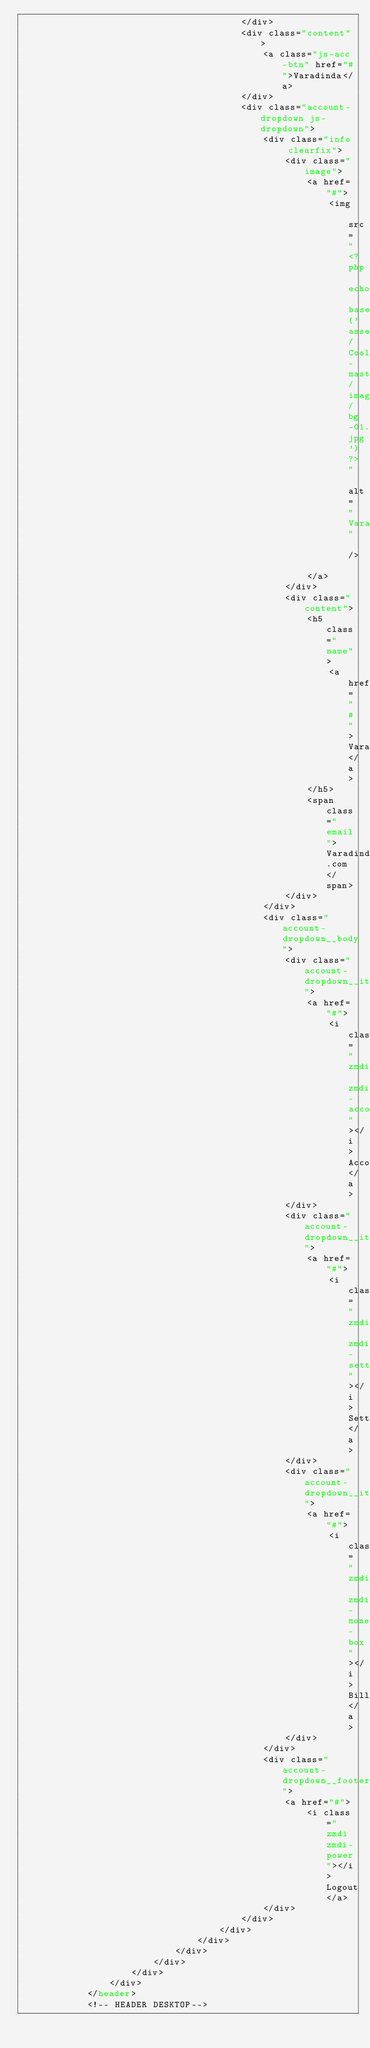<code> <loc_0><loc_0><loc_500><loc_500><_PHP_>                                        </div>
                                        <div class="content">
                                            <a class="js-acc-btn" href="#">Varadinda</a>
                                        </div>
                                        <div class="account-dropdown js-dropdown">
                                            <div class="info clearfix">
                                                <div class="image">
                                                    <a href="#">
                                                        <img src="<?php echo base_url('assets/Cooladmin-master/images/bg-01.jpg')?>" alt="Varadinda" />
                                                    </a>
                                                </div>
                                                <div class="content">
                                                    <h5 class="name">
                                                        <a href="#">Varadinda</a>
                                                    </h5>
                                                    <span class="email">Varadinda@gmail.com</span>
                                                </div>
                                            </div>
                                            <div class="account-dropdown__body">
                                                <div class="account-dropdown__item">
                                                    <a href="#">
                                                        <i class="zmdi zmdi-account"></i>Account</a>
                                                </div>
                                                <div class="account-dropdown__item">
                                                    <a href="#">
                                                        <i class="zmdi zmdi-settings"></i>Setting</a>
                                                </div>
                                                <div class="account-dropdown__item">
                                                    <a href="#">
                                                        <i class="zmdi zmdi-money-box"></i>Billing</a>
                                                </div>
                                            </div>
                                            <div class="account-dropdown__footer">
                                                <a href="#">
                                                    <i class="zmdi zmdi-power"></i>Logout</a>
                                            </div>
                                        </div>
                                    </div>
                                </div>
                            </div>
                        </div>
                    </div>
                </div>
            </header>
            <!-- HEADER DESKTOP-->
</code> 